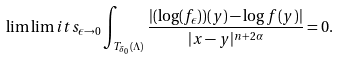<formula> <loc_0><loc_0><loc_500><loc_500>\lim \lim i t s _ { \epsilon \to 0 } \int _ { T _ { \delta _ { 0 } } ( \Lambda ) } \frac { | ( \log ( f _ { \epsilon } ) ) ( y ) - \log f ( y ) | } { | x - y | ^ { n + 2 \alpha } } = 0 .</formula> 